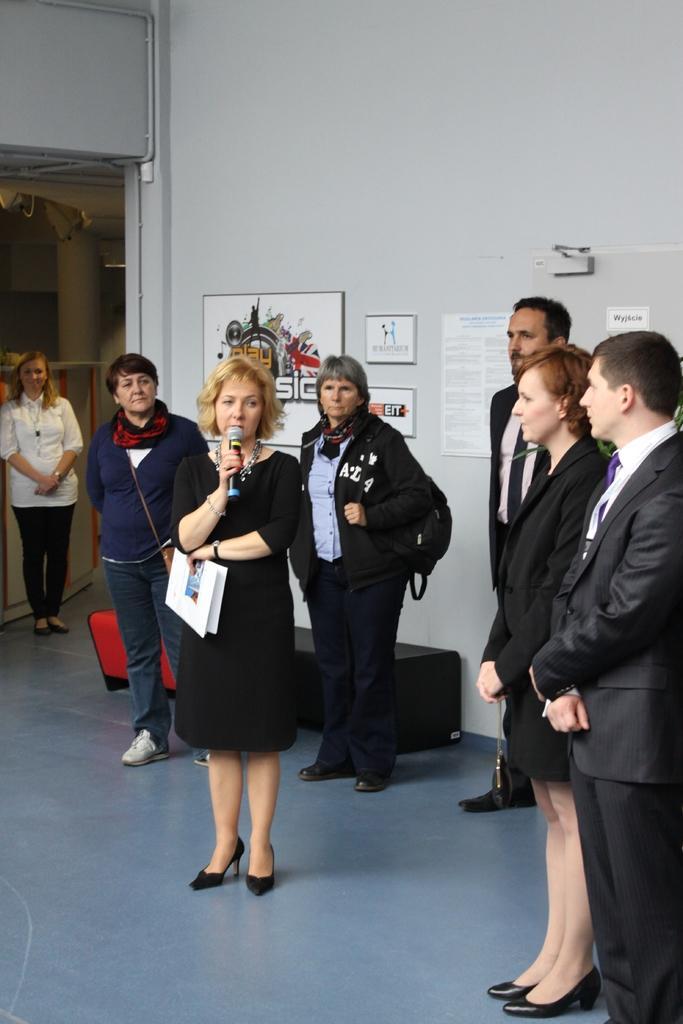In one or two sentences, can you explain what this image depicts? In this image there are group of persons standing. In the center there is a woman standing and holding a paper in her hand and holding a mic and speaking. In the background there is a wall and on the wall there are frames and there is a bench which is black and red in colour. 